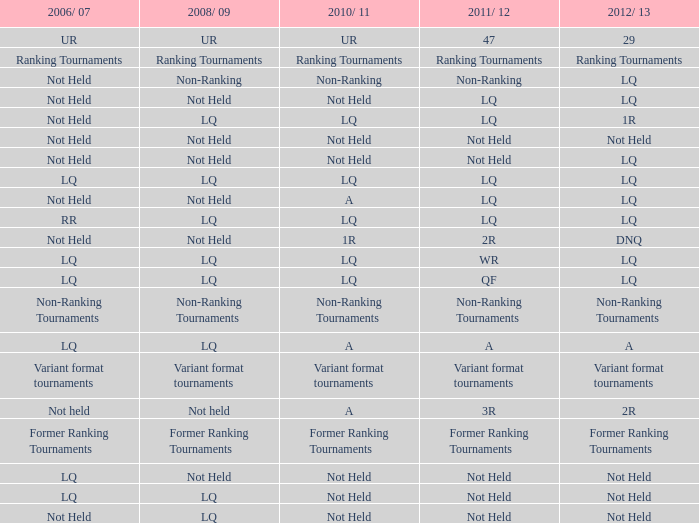What is 2006/07, when 2008/09 is LQ, when 2012/13 is LQ, and when 2011/12 is WR? LQ. 